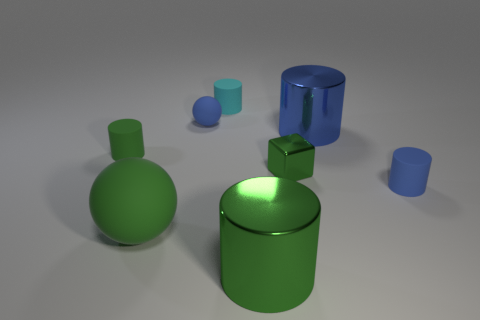Add 2 big green balls. How many objects exist? 10 Subtract all cyan cylinders. How many cylinders are left? 4 Subtract all tiny blue cylinders. How many cylinders are left? 4 Subtract 0 brown cubes. How many objects are left? 8 Subtract all cubes. How many objects are left? 7 Subtract 1 blocks. How many blocks are left? 0 Subtract all yellow blocks. Subtract all gray balls. How many blocks are left? 1 Subtract all brown cylinders. How many green balls are left? 1 Subtract all small rubber cylinders. Subtract all blue cylinders. How many objects are left? 3 Add 7 large green rubber spheres. How many large green rubber spheres are left? 8 